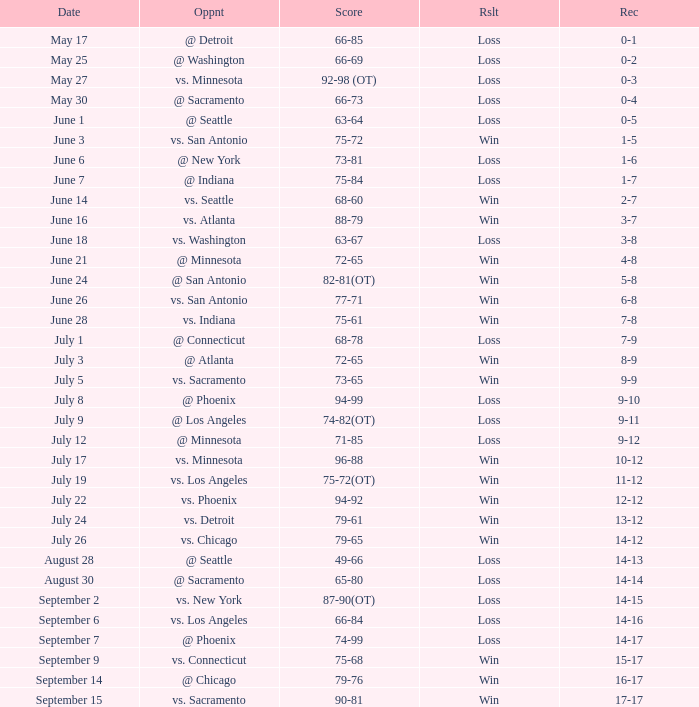What was the Score of the game with a Record of 0-1? 66-85. 